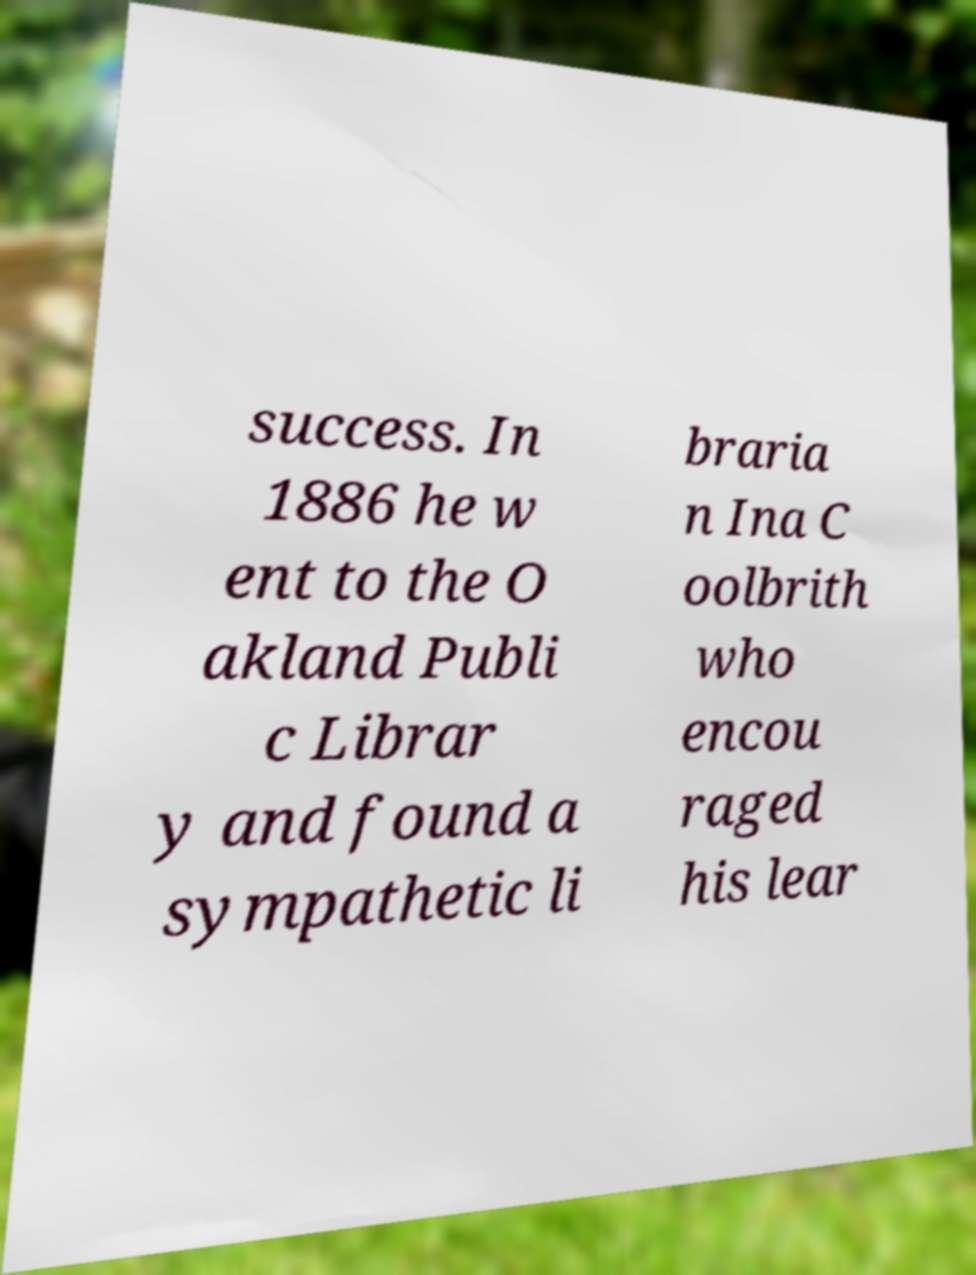What messages or text are displayed in this image? I need them in a readable, typed format. success. In 1886 he w ent to the O akland Publi c Librar y and found a sympathetic li braria n Ina C oolbrith who encou raged his lear 